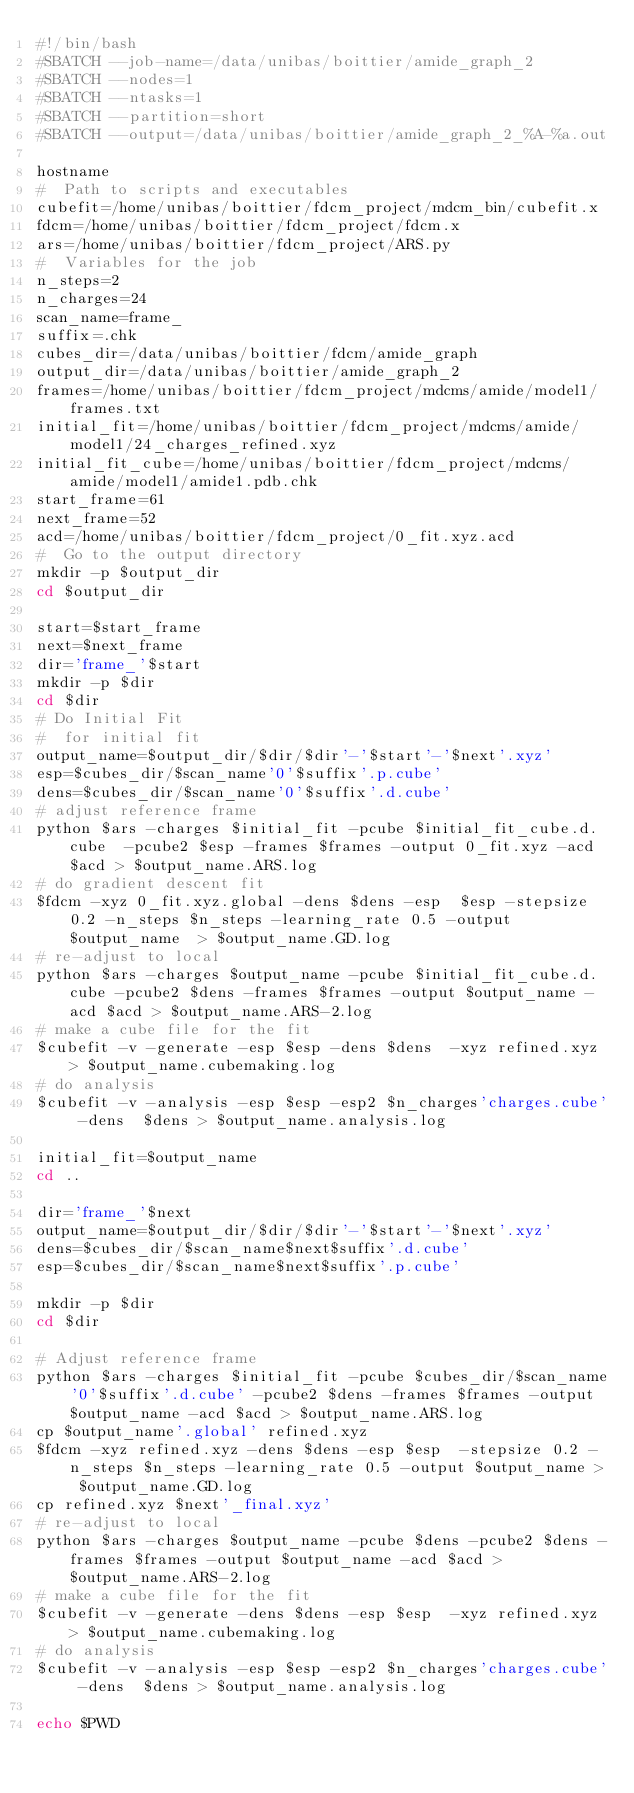Convert code to text. <code><loc_0><loc_0><loc_500><loc_500><_Bash_>#!/bin/bash
#SBATCH --job-name=/data/unibas/boittier/amide_graph_2
#SBATCH --nodes=1
#SBATCH --ntasks=1
#SBATCH --partition=short
#SBATCH --output=/data/unibas/boittier/amide_graph_2_%A-%a.out

hostname
#  Path to scripts and executables
cubefit=/home/unibas/boittier/fdcm_project/mdcm_bin/cubefit.x
fdcm=/home/unibas/boittier/fdcm_project/fdcm.x
ars=/home/unibas/boittier/fdcm_project/ARS.py
#  Variables for the job
n_steps=2
n_charges=24
scan_name=frame_
suffix=.chk
cubes_dir=/data/unibas/boittier/fdcm/amide_graph
output_dir=/data/unibas/boittier/amide_graph_2
frames=/home/unibas/boittier/fdcm_project/mdcms/amide/model1/frames.txt
initial_fit=/home/unibas/boittier/fdcm_project/mdcms/amide/model1/24_charges_refined.xyz
initial_fit_cube=/home/unibas/boittier/fdcm_project/mdcms/amide/model1/amide1.pdb.chk
start_frame=61
next_frame=52
acd=/home/unibas/boittier/fdcm_project/0_fit.xyz.acd
#  Go to the output directory
mkdir -p $output_dir
cd $output_dir

start=$start_frame
next=$next_frame
dir='frame_'$start
mkdir -p $dir
cd $dir
# Do Initial Fit
#  for initial fit
output_name=$output_dir/$dir/$dir'-'$start'-'$next'.xyz'
esp=$cubes_dir/$scan_name'0'$suffix'.p.cube'
dens=$cubes_dir/$scan_name'0'$suffix'.d.cube'
# adjust reference frame
python $ars -charges $initial_fit -pcube $initial_fit_cube.d.cube  -pcube2 $esp -frames $frames -output 0_fit.xyz -acd $acd > $output_name.ARS.log
# do gradient descent fit
$fdcm -xyz 0_fit.xyz.global -dens $dens -esp  $esp -stepsize 0.2 -n_steps $n_steps -learning_rate 0.5 -output $output_name  > $output_name.GD.log
# re-adjust to local
python $ars -charges $output_name -pcube $initial_fit_cube.d.cube -pcube2 $dens -frames $frames -output $output_name -acd $acd > $output_name.ARS-2.log
# make a cube file for the fit
$cubefit -v -generate -esp $esp -dens $dens  -xyz refined.xyz > $output_name.cubemaking.log
# do analysis
$cubefit -v -analysis -esp $esp -esp2 $n_charges'charges.cube' -dens  $dens > $output_name.analysis.log

initial_fit=$output_name
cd ..

dir='frame_'$next
output_name=$output_dir/$dir/$dir'-'$start'-'$next'.xyz'
dens=$cubes_dir/$scan_name$next$suffix'.d.cube'
esp=$cubes_dir/$scan_name$next$suffix'.p.cube'

mkdir -p $dir
cd $dir

# Adjust reference frame
python $ars -charges $initial_fit -pcube $cubes_dir/$scan_name'0'$suffix'.d.cube' -pcube2 $dens -frames $frames -output $output_name -acd $acd > $output_name.ARS.log
cp $output_name'.global' refined.xyz
$fdcm -xyz refined.xyz -dens $dens -esp $esp  -stepsize 0.2 -n_steps $n_steps -learning_rate 0.5 -output $output_name > $output_name.GD.log
cp refined.xyz $next'_final.xyz'
# re-adjust to local
python $ars -charges $output_name -pcube $dens -pcube2 $dens -frames $frames -output $output_name -acd $acd > $output_name.ARS-2.log
# make a cube file for the fit
$cubefit -v -generate -dens $dens -esp $esp  -xyz refined.xyz > $output_name.cubemaking.log
# do analysis
$cubefit -v -analysis -esp $esp -esp2 $n_charges'charges.cube' -dens  $dens > $output_name.analysis.log

echo $PWD



</code> 